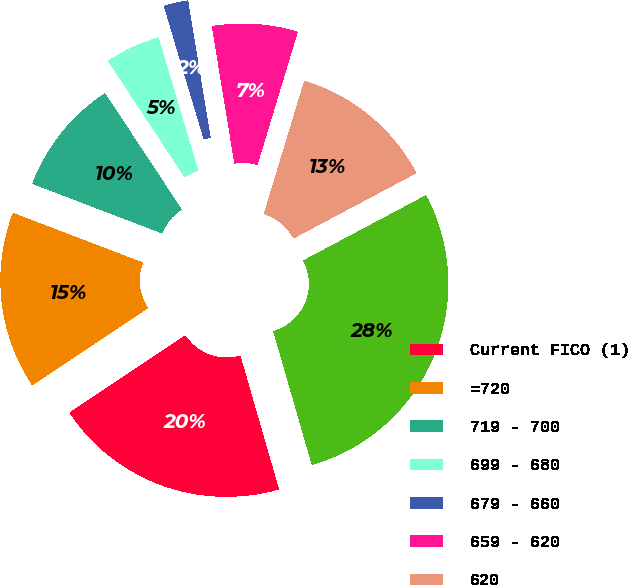Convert chart to OTSL. <chart><loc_0><loc_0><loc_500><loc_500><pie_chart><fcel>Current FICO (1)<fcel>=720<fcel>719 - 700<fcel>699 - 680<fcel>679 - 660<fcel>659 - 620<fcel>620<fcel>Total mortgage loans<nl><fcel>20.11%<fcel>15.17%<fcel>9.91%<fcel>4.66%<fcel>2.03%<fcel>7.28%<fcel>12.54%<fcel>28.3%<nl></chart> 